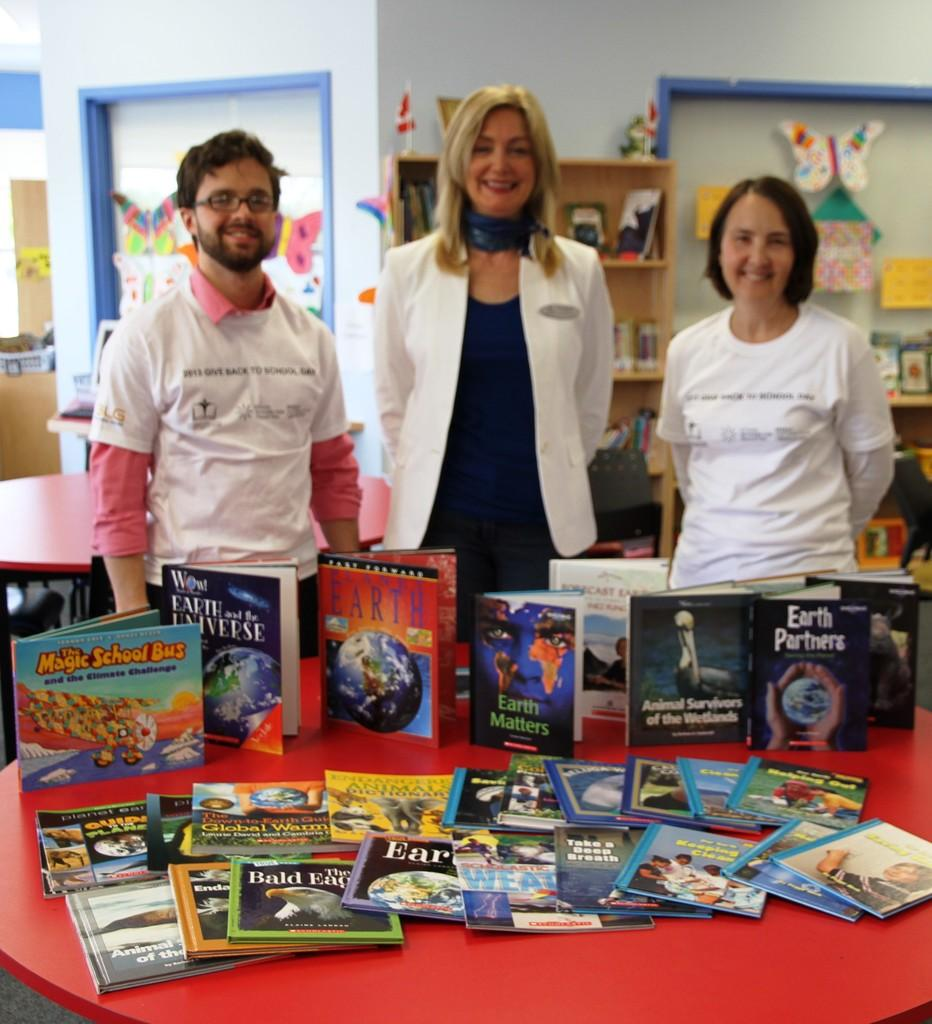Provide a one-sentence caption for the provided image. A book titled "The magic school bus and the climate challenge". 